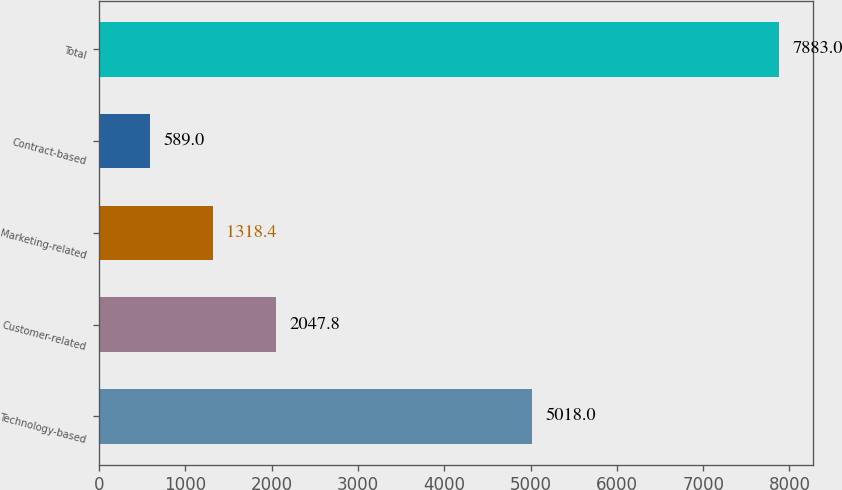Convert chart to OTSL. <chart><loc_0><loc_0><loc_500><loc_500><bar_chart><fcel>Technology-based<fcel>Customer-related<fcel>Marketing-related<fcel>Contract-based<fcel>Total<nl><fcel>5018<fcel>2047.8<fcel>1318.4<fcel>589<fcel>7883<nl></chart> 